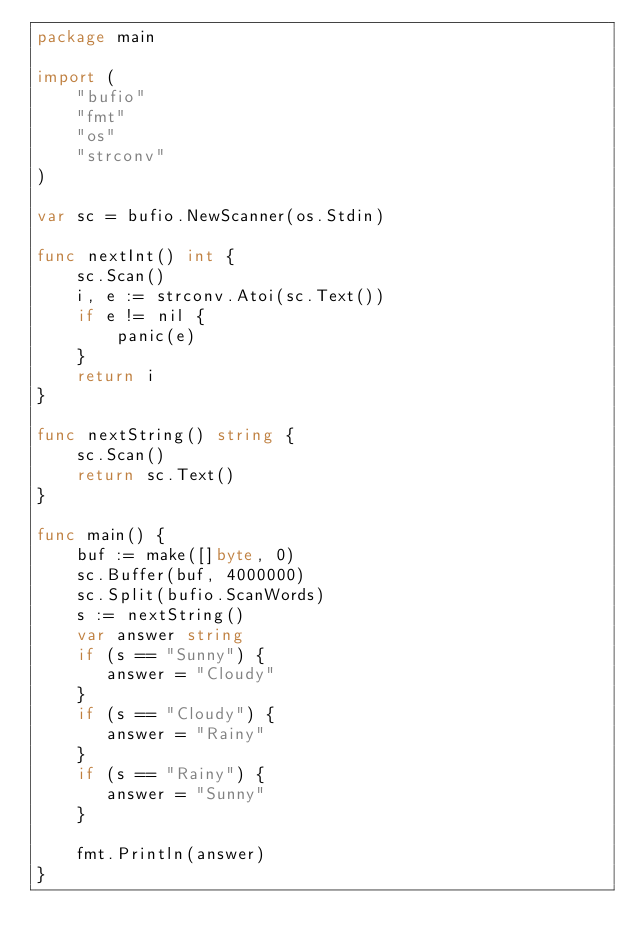Convert code to text. <code><loc_0><loc_0><loc_500><loc_500><_Go_>package main

import (
    "bufio"
    "fmt"
    "os"
    "strconv"
)

var sc = bufio.NewScanner(os.Stdin)

func nextInt() int {
    sc.Scan()
    i, e := strconv.Atoi(sc.Text())
    if e != nil {
        panic(e)
    }
    return i
}

func nextString() string {
    sc.Scan()
    return sc.Text()
}

func main() {
    buf := make([]byte, 0)
    sc.Buffer(buf, 4000000)
    sc.Split(bufio.ScanWords)
    s := nextString()
    var answer string
    if (s == "Sunny") {
       answer = "Cloudy" 
    }
    if (s == "Cloudy") {
       answer = "Rainy" 
    }
    if (s == "Rainy") {
       answer = "Sunny" 
    }
    
    fmt.Println(answer)
}</code> 